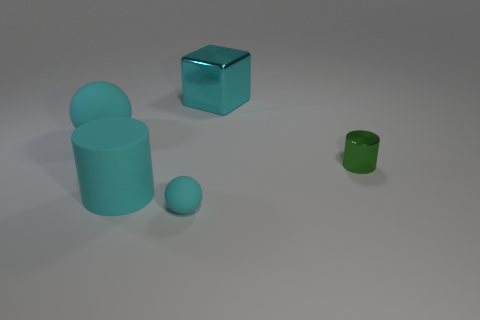Add 4 large cyan blocks. How many objects exist? 9 Subtract all blocks. How many objects are left? 4 Add 3 big spheres. How many big spheres are left? 4 Add 5 tiny metallic cylinders. How many tiny metallic cylinders exist? 6 Subtract 0 yellow blocks. How many objects are left? 5 Subtract all big rubber cylinders. Subtract all tiny green things. How many objects are left? 3 